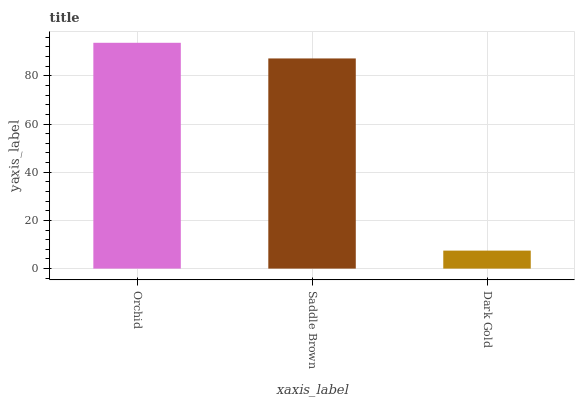Is Dark Gold the minimum?
Answer yes or no. Yes. Is Orchid the maximum?
Answer yes or no. Yes. Is Saddle Brown the minimum?
Answer yes or no. No. Is Saddle Brown the maximum?
Answer yes or no. No. Is Orchid greater than Saddle Brown?
Answer yes or no. Yes. Is Saddle Brown less than Orchid?
Answer yes or no. Yes. Is Saddle Brown greater than Orchid?
Answer yes or no. No. Is Orchid less than Saddle Brown?
Answer yes or no. No. Is Saddle Brown the high median?
Answer yes or no. Yes. Is Saddle Brown the low median?
Answer yes or no. Yes. Is Orchid the high median?
Answer yes or no. No. Is Dark Gold the low median?
Answer yes or no. No. 